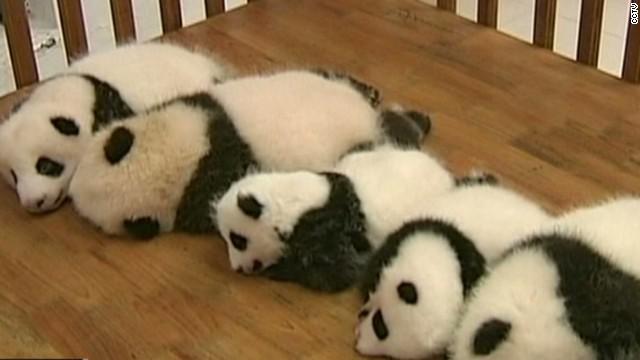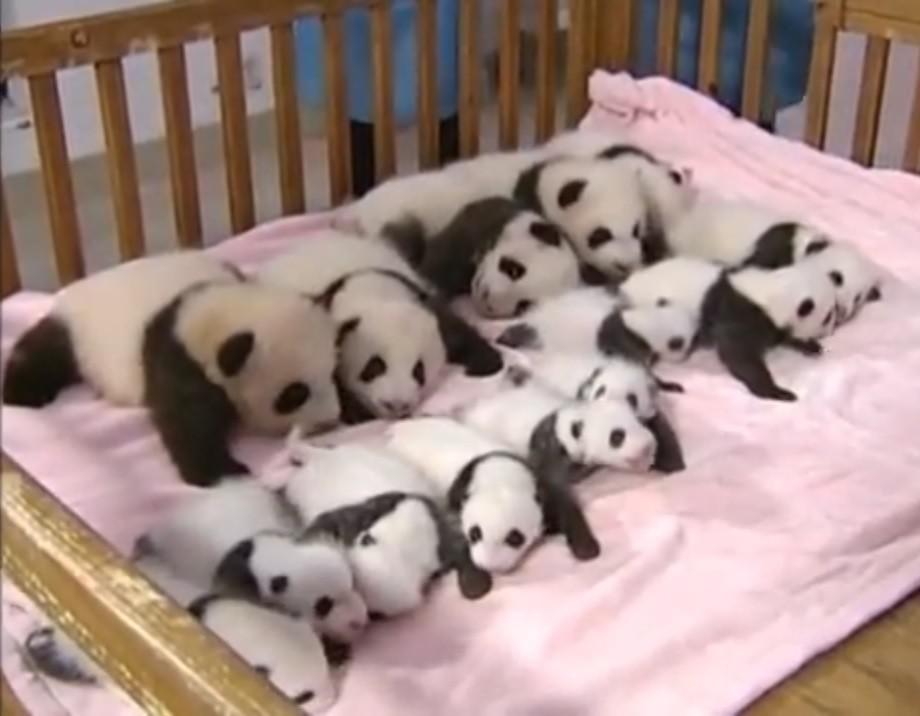The first image is the image on the left, the second image is the image on the right. Analyze the images presented: Is the assertion "The left image contains baby pandas sleeping on a pink blanket." valid? Answer yes or no. No. The first image is the image on the left, the second image is the image on the right. Analyze the images presented: Is the assertion "An image shows rows of pandas sleeping on a pink blanket surrounded by rails, and a green ball is next to the blanket." valid? Answer yes or no. No. 